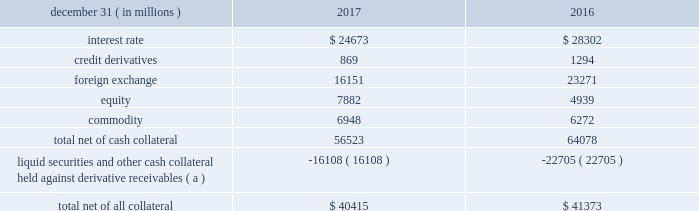Management 2019s discussion and analysis 114 jpmorgan chase & co./2017 annual report derivative contracts in the normal course of business , the firm uses derivative instruments predominantly for market-making activities .
Derivatives enable counterparties to manage exposures to fluctuations in interest rates , currencies and other markets .
The firm also uses derivative instruments to manage its own credit and other market risk exposure .
The nature of the counterparty and the settlement mechanism of the derivative affect the credit risk to which the firm is exposed .
For otc derivatives the firm is exposed to the credit risk of the derivative counterparty .
For exchange- traded derivatives ( 201cetd 201d ) , such as futures and options , and 201ccleared 201d over-the-counter ( 201cotc-cleared 201d ) derivatives , the firm is generally exposed to the credit risk of the relevant ccp .
Where possible , the firm seeks to mitigate its credit risk exposures arising from derivative transactions through the use of legally enforceable master netting arrangements and collateral agreements .
For further discussion of derivative contracts , counterparties and settlement types , see note 5 .
The table summarizes the net derivative receivables for the periods presented .
Derivative receivables .
( a ) includes collateral related to derivative instruments where an appropriate legal opinion has not been either sought or obtained .
Derivative receivables reported on the consolidated balance sheets were $ 56.5 billion and $ 64.1 billion at december 31 , 2017 and 2016 , respectively .
Derivative receivables decreased predominantly as a result of client- driven market-making activities in cib markets , which reduced foreign exchange and interest rate derivative receivables , and increased equity derivative receivables , driven by market movements .
Derivative receivables amounts represent the fair value of the derivative contracts after giving effect to legally enforceable master netting agreements and cash collateral held by the firm .
However , in management 2019s view , the appropriate measure of current credit risk should also take into consideration additional liquid securities ( primarily u.s .
Government and agency securities and other group of seven nations ( 201cg7 201d ) government bonds ) and other cash collateral held by the firm aggregating $ 16.1 billion and $ 22.7 billion at december 31 , 2017 and 2016 , respectively , that may be used as security when the fair value of the client 2019s exposure is in the firm 2019s favor .
In addition to the collateral described in the preceding paragraph , the firm also holds additional collateral ( primarily cash , g7 government securities , other liquid government-agency and guaranteed securities , and corporate debt and equity securities ) delivered by clients at the initiation of transactions , as well as collateral related to contracts that have a non-daily call frequency and collateral that the firm has agreed to return but has not yet settled as of the reporting date .
Although this collateral does not reduce the balances and is not included in the table above , it is available as security against potential exposure that could arise should the fair value of the client 2019s derivative transactions move in the firm 2019s favor .
The derivative receivables fair value , net of all collateral , also does not include other credit enhancements , such as letters of credit .
For additional information on the firm 2019s use of collateral agreements , see note 5 .
While useful as a current view of credit exposure , the net fair value of the derivative receivables does not capture the potential future variability of that credit exposure .
To capture the potential future variability of credit exposure , the firm calculates , on a client-by-client basis , three measures of potential derivatives-related credit loss : peak , derivative risk equivalent ( 201cdre 201d ) , and average exposure ( 201cavg 201d ) .
These measures all incorporate netting and collateral benefits , where applicable .
Peak represents a conservative measure of potential exposure to a counterparty calculated in a manner that is broadly equivalent to a 97.5% ( 97.5 % ) confidence level over the life of the transaction .
Peak is the primary measure used by the firm for setting of credit limits for derivative transactions , senior management reporting and derivatives exposure management .
Dre exposure is a measure that expresses the risk of derivative exposure on a basis intended to be equivalent to the risk of loan exposures .
Dre is a less extreme measure of potential credit loss than peak and is used for aggregating derivative credit risk exposures with loans and other credit risk .
Finally , avg is a measure of the expected fair value of the firm 2019s derivative receivables at future time periods , including the benefit of collateral .
Avg exposure over the total life of the derivative contract is used as the primary metric for pricing purposes and is used to calculate credit risk capital and the cva , as further described below .
The three year avg exposure was $ 29.0 billion and $ 31.1 billion at december 31 , 2017 and 2016 , respectively , compared with derivative receivables , net of all collateral , of $ 40.4 billion and $ 41.4 billion at december 31 , 2017 and 2016 , respectively .
The fair value of the firm 2019s derivative receivables incorporates cva to reflect the credit quality of counterparties .
Cva is based on the firm 2019s avg to a counterparty and the counterparty 2019s credit spread in the credit derivatives market .
The firm believes that active risk management is essential to controlling the dynamic credit risk in the derivatives portfolio .
In addition , the firm 2019s risk management process takes into consideration the potential .
What was the percent of avg exposure on the 2017 derivative receivables? 
Computations: (29.0 / 40.4)
Answer: 0.71782. Management 2019s discussion and analysis 114 jpmorgan chase & co./2017 annual report derivative contracts in the normal course of business , the firm uses derivative instruments predominantly for market-making activities .
Derivatives enable counterparties to manage exposures to fluctuations in interest rates , currencies and other markets .
The firm also uses derivative instruments to manage its own credit and other market risk exposure .
The nature of the counterparty and the settlement mechanism of the derivative affect the credit risk to which the firm is exposed .
For otc derivatives the firm is exposed to the credit risk of the derivative counterparty .
For exchange- traded derivatives ( 201cetd 201d ) , such as futures and options , and 201ccleared 201d over-the-counter ( 201cotc-cleared 201d ) derivatives , the firm is generally exposed to the credit risk of the relevant ccp .
Where possible , the firm seeks to mitigate its credit risk exposures arising from derivative transactions through the use of legally enforceable master netting arrangements and collateral agreements .
For further discussion of derivative contracts , counterparties and settlement types , see note 5 .
The table summarizes the net derivative receivables for the periods presented .
Derivative receivables .
( a ) includes collateral related to derivative instruments where an appropriate legal opinion has not been either sought or obtained .
Derivative receivables reported on the consolidated balance sheets were $ 56.5 billion and $ 64.1 billion at december 31 , 2017 and 2016 , respectively .
Derivative receivables decreased predominantly as a result of client- driven market-making activities in cib markets , which reduced foreign exchange and interest rate derivative receivables , and increased equity derivative receivables , driven by market movements .
Derivative receivables amounts represent the fair value of the derivative contracts after giving effect to legally enforceable master netting agreements and cash collateral held by the firm .
However , in management 2019s view , the appropriate measure of current credit risk should also take into consideration additional liquid securities ( primarily u.s .
Government and agency securities and other group of seven nations ( 201cg7 201d ) government bonds ) and other cash collateral held by the firm aggregating $ 16.1 billion and $ 22.7 billion at december 31 , 2017 and 2016 , respectively , that may be used as security when the fair value of the client 2019s exposure is in the firm 2019s favor .
In addition to the collateral described in the preceding paragraph , the firm also holds additional collateral ( primarily cash , g7 government securities , other liquid government-agency and guaranteed securities , and corporate debt and equity securities ) delivered by clients at the initiation of transactions , as well as collateral related to contracts that have a non-daily call frequency and collateral that the firm has agreed to return but has not yet settled as of the reporting date .
Although this collateral does not reduce the balances and is not included in the table above , it is available as security against potential exposure that could arise should the fair value of the client 2019s derivative transactions move in the firm 2019s favor .
The derivative receivables fair value , net of all collateral , also does not include other credit enhancements , such as letters of credit .
For additional information on the firm 2019s use of collateral agreements , see note 5 .
While useful as a current view of credit exposure , the net fair value of the derivative receivables does not capture the potential future variability of that credit exposure .
To capture the potential future variability of credit exposure , the firm calculates , on a client-by-client basis , three measures of potential derivatives-related credit loss : peak , derivative risk equivalent ( 201cdre 201d ) , and average exposure ( 201cavg 201d ) .
These measures all incorporate netting and collateral benefits , where applicable .
Peak represents a conservative measure of potential exposure to a counterparty calculated in a manner that is broadly equivalent to a 97.5% ( 97.5 % ) confidence level over the life of the transaction .
Peak is the primary measure used by the firm for setting of credit limits for derivative transactions , senior management reporting and derivatives exposure management .
Dre exposure is a measure that expresses the risk of derivative exposure on a basis intended to be equivalent to the risk of loan exposures .
Dre is a less extreme measure of potential credit loss than peak and is used for aggregating derivative credit risk exposures with loans and other credit risk .
Finally , avg is a measure of the expected fair value of the firm 2019s derivative receivables at future time periods , including the benefit of collateral .
Avg exposure over the total life of the derivative contract is used as the primary metric for pricing purposes and is used to calculate credit risk capital and the cva , as further described below .
The three year avg exposure was $ 29.0 billion and $ 31.1 billion at december 31 , 2017 and 2016 , respectively , compared with derivative receivables , net of all collateral , of $ 40.4 billion and $ 41.4 billion at december 31 , 2017 and 2016 , respectively .
The fair value of the firm 2019s derivative receivables incorporates cva to reflect the credit quality of counterparties .
Cva is based on the firm 2019s avg to a counterparty and the counterparty 2019s credit spread in the credit derivatives market .
The firm believes that active risk management is essential to controlling the dynamic credit risk in the derivatives portfolio .
In addition , the firm 2019s risk management process takes into consideration the potential .
In 2017 what was the percent of the total net of cash collateral that was foreign exchange? 
Computations: (16151 / 56523)
Answer: 0.28574. 